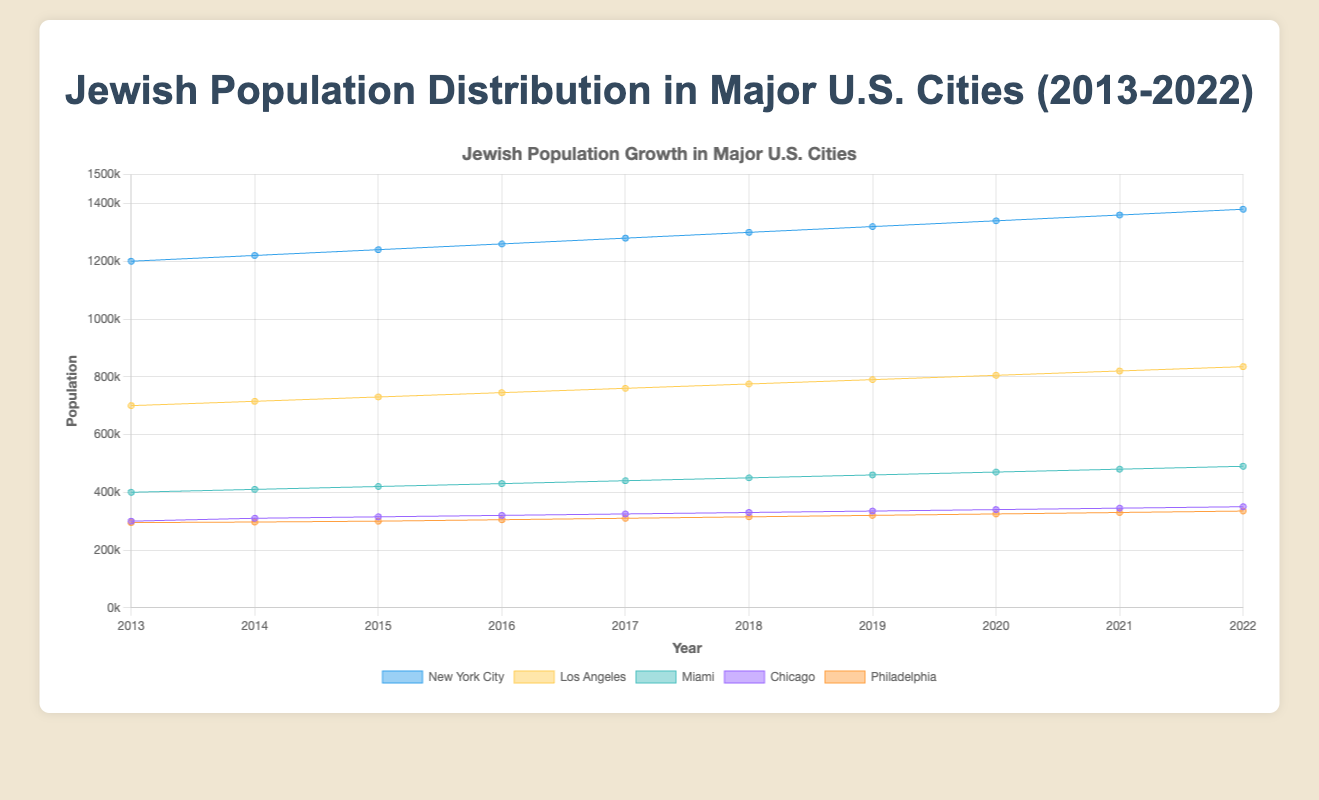What is the title of the figure? The title of the figure is displayed at the top and should clearly indicate what the chart is about. In this case, it's about the Jewish population distribution in major U.S. cities from 2013 to 2022.
Answer: Jewish Population Distribution in Major U.S. Cities (2013-2022) Which city had the highest population of Jewish people in 2022? By looking at the figure, we can compare the height of the areas corresponding to each city in 2022. The city with the highest area is New York City.
Answer: New York City Between which two consecutive years did Miami experience the highest increase in Jewish population? Observe the slope of the lines corresponding to Miami for each year. The steepest slope indicates the highest increase. The most significant increase is between 2019 and 2020.
Answer: 2019 and 2020 What is the total increase in the Jewish population in New York City from 2013 to 2022? Calculate the difference between the population in 2022 and 2013 for New York City. From the chart, New York City had 1,380,000 in 2022 and 1,200,000 in 2013. So, the increase is 1,380,000 - 1,200,000 = 180,000.
Answer: 180,000 Compare the growth trends of Chicago and Philadelphia. Which city had a more stable growth? By examining the lines representing Chicago and Philadelphia, we can determine which line is smoother and less variable. Philadelphia's growth appears more stable with less fluctuation compared to Chicago's growth pattern.
Answer: Philadelphia Calculate the average Jewish population in Los Angeles over the decade. Sum the Los Angeles population values for each year from the chart and divide by the number of years: (700,000 + 715,000 + 730,000 + 745,000 + 760,000 + 775,000 + 790,000 + 805,000 + 820,000 + 835,000) / 10 = 7,375,000 / 10 = 737,500.
Answer: 737,500 Which city had the smallest population in 2013, and what was that population? Look at the areas representing each city in 2013. The city with the smallest area is Philadelphia, with a population of 295,000.
Answer: Philadelphia, 295,000 How much did the Jewish population in Miami change from 2017 to 2018? Examine the population values for Miami in 2017 and 2018. Subtract the 2017 value from the 2018 value: 450,000 - 440,000 = 10,000.
Answer: 10,000 What is the average annual growth rate of the Jewish population in New York City between 2013 and 2022? Calculate the total increase in population, which is 180,000, and divide by the number of years (9): 180,000 / 9 = 20,000.
Answer: 20,000 per year 